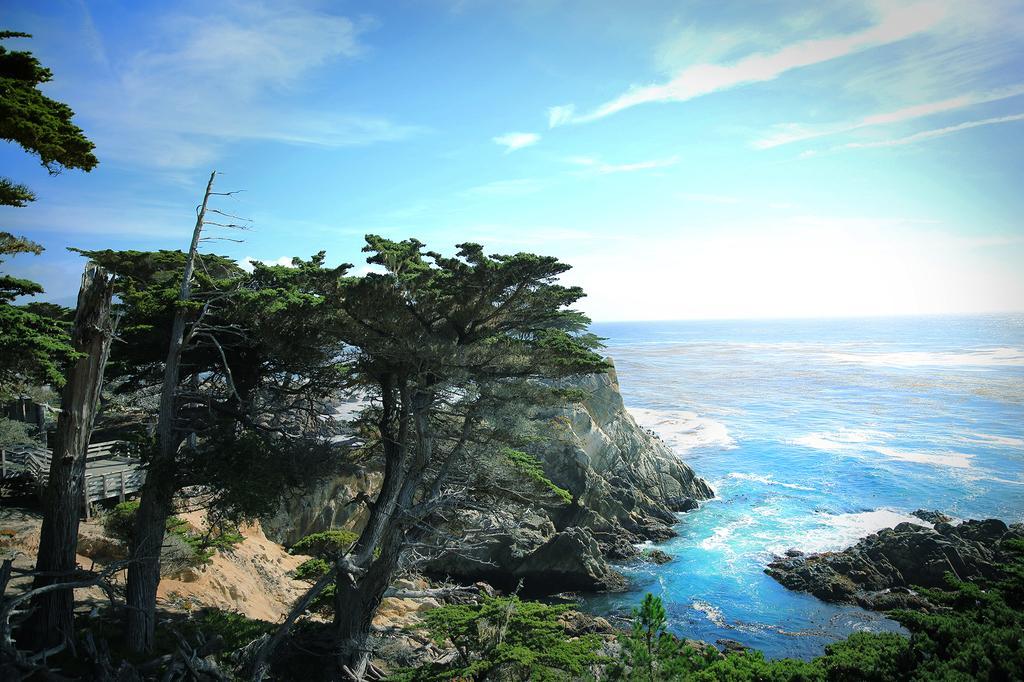Describe this image in one or two sentences. This picture is clicked outside. In the foreground we can see the plants, trees and the rocks. In the center we can see a water body. On the left there is a bridge like thing. In the background we can see the sky with the clouds. 